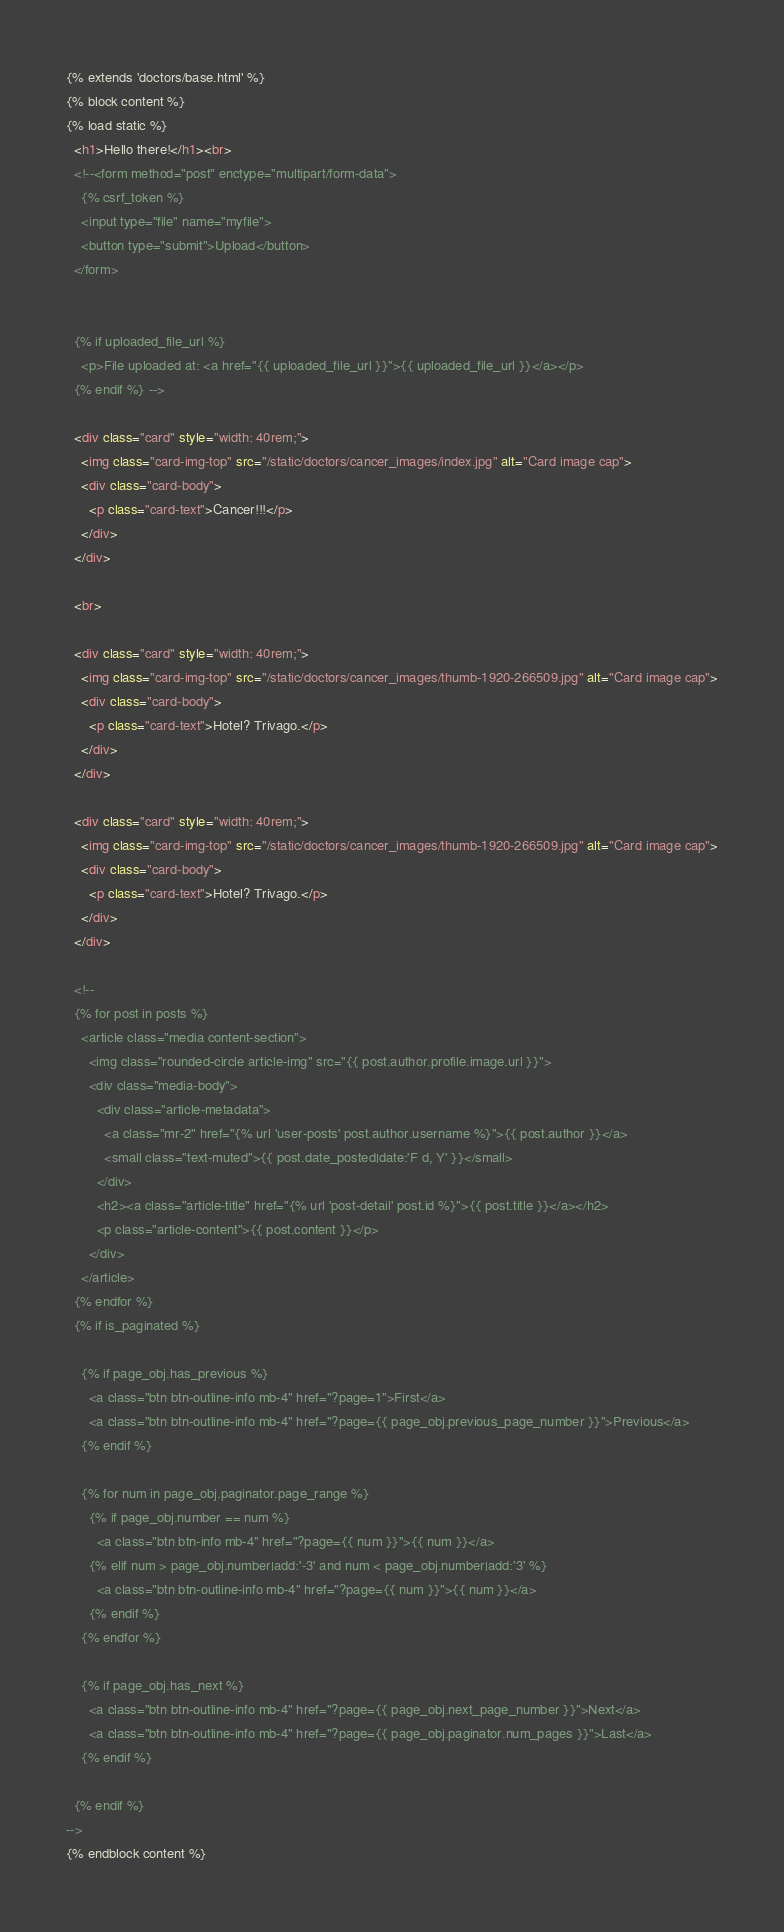Convert code to text. <code><loc_0><loc_0><loc_500><loc_500><_HTML_>{% extends 'doctors/base.html' %}
{% block content %}
{% load static %}
  <h1>Hello there!</h1><br>
  <!--<form method="post" enctype="multipart/form-data">
    {% csrf_token %}
    <input type="file" name="myfile">
    <button type="submit">Upload</button>
  </form>


  {% if uploaded_file_url %}
    <p>File uploaded at: <a href="{{ uploaded_file_url }}">{{ uploaded_file_url }}</a></p>
  {% endif %} -->

  <div class="card" style="width: 40rem;">
    <img class="card-img-top" src="/static/doctors/cancer_images/index.jpg" alt="Card image cap">
    <div class="card-body">
      <p class="card-text">Cancer!!!</p>
    </div>
  </div>

  <br>

  <div class="card" style="width: 40rem;">
    <img class="card-img-top" src="/static/doctors/cancer_images/thumb-1920-266509.jpg" alt="Card image cap">
    <div class="card-body">
      <p class="card-text">Hotel? Trivago.</p>
    </div>
  </div>

  <div class="card" style="width: 40rem;">
    <img class="card-img-top" src="/static/doctors/cancer_images/thumb-1920-266509.jpg" alt="Card image cap">
    <div class="card-body">
      <p class="card-text">Hotel? Trivago.</p>
    </div>
  </div>

  <!--
  {% for post in posts %}
    <article class="media content-section">
      <img class="rounded-circle article-img" src="{{ post.author.profile.image.url }}">
      <div class="media-body">
        <div class="article-metadata">
          <a class="mr-2" href="{% url 'user-posts' post.author.username %}">{{ post.author }}</a>
          <small class="text-muted">{{ post.date_posted|date:'F d, Y' }}</small>
        </div>
        <h2><a class="article-title" href="{% url 'post-detail' post.id %}">{{ post.title }}</a></h2>
        <p class="article-content">{{ post.content }}</p>
      </div>
    </article>
  {% endfor %}
  {% if is_paginated %}

    {% if page_obj.has_previous %}
      <a class="btn btn-outline-info mb-4" href="?page=1">First</a>
      <a class="btn btn-outline-info mb-4" href="?page={{ page_obj.previous_page_number }}">Previous</a>
    {% endif %}

    {% for num in page_obj.paginator.page_range %}
      {% if page_obj.number == num %}
        <a class="btn btn-info mb-4" href="?page={{ num }}">{{ num }}</a>
      {% elif num > page_obj.number|add:'-3' and num < page_obj.number|add:'3' %}
        <a class="btn btn-outline-info mb-4" href="?page={{ num }}">{{ num }}</a>
      {% endif %}
    {% endfor %}

    {% if page_obj.has_next %}
      <a class="btn btn-outline-info mb-4" href="?page={{ page_obj.next_page_number }}">Next</a>
      <a class="btn btn-outline-info mb-4" href="?page={{ page_obj.paginator.num_pages }}">Last</a>
    {% endif %}

  {% endif %}
-->
{% endblock content %}
</code> 